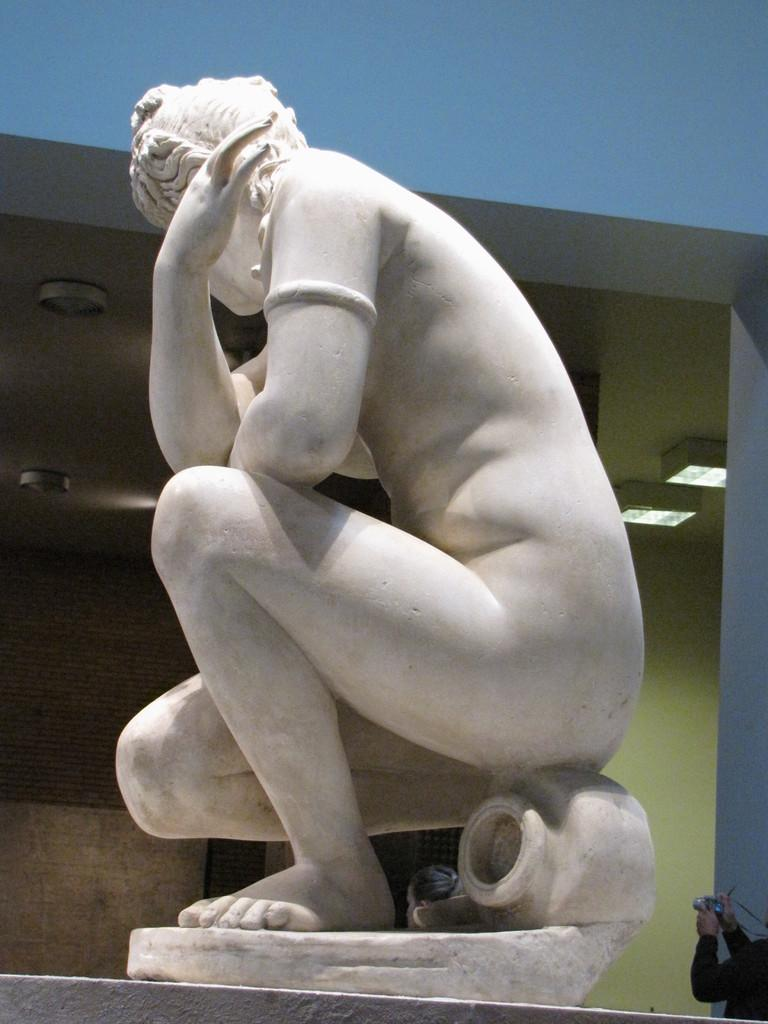What is the main subject in the middle of the image? There is a statue in the middle of the image. What can be seen in the background of the image? There are lights in the background of the image. Where is the person holding a camera located in the image? The person holding a camera is located at the right bottom of the image. What type of baseball equipment can be seen in the image? There is no baseball equipment present in the image. How many doors are visible in the image? There is no door visible in the image. 